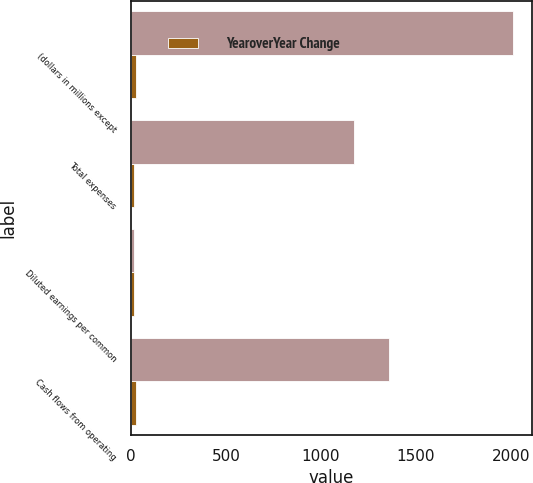Convert chart to OTSL. <chart><loc_0><loc_0><loc_500><loc_500><stacked_bar_chart><ecel><fcel>(dollars in millions except<fcel>Total expenses<fcel>Diluted earnings per common<fcel>Cash flows from operating<nl><fcel>nan<fcel>2010<fcel>1172.6<fcel>14.31<fcel>1356.4<nl><fcel>YearoverYear Change<fcel>25<fcel>15<fcel>15<fcel>25<nl></chart> 